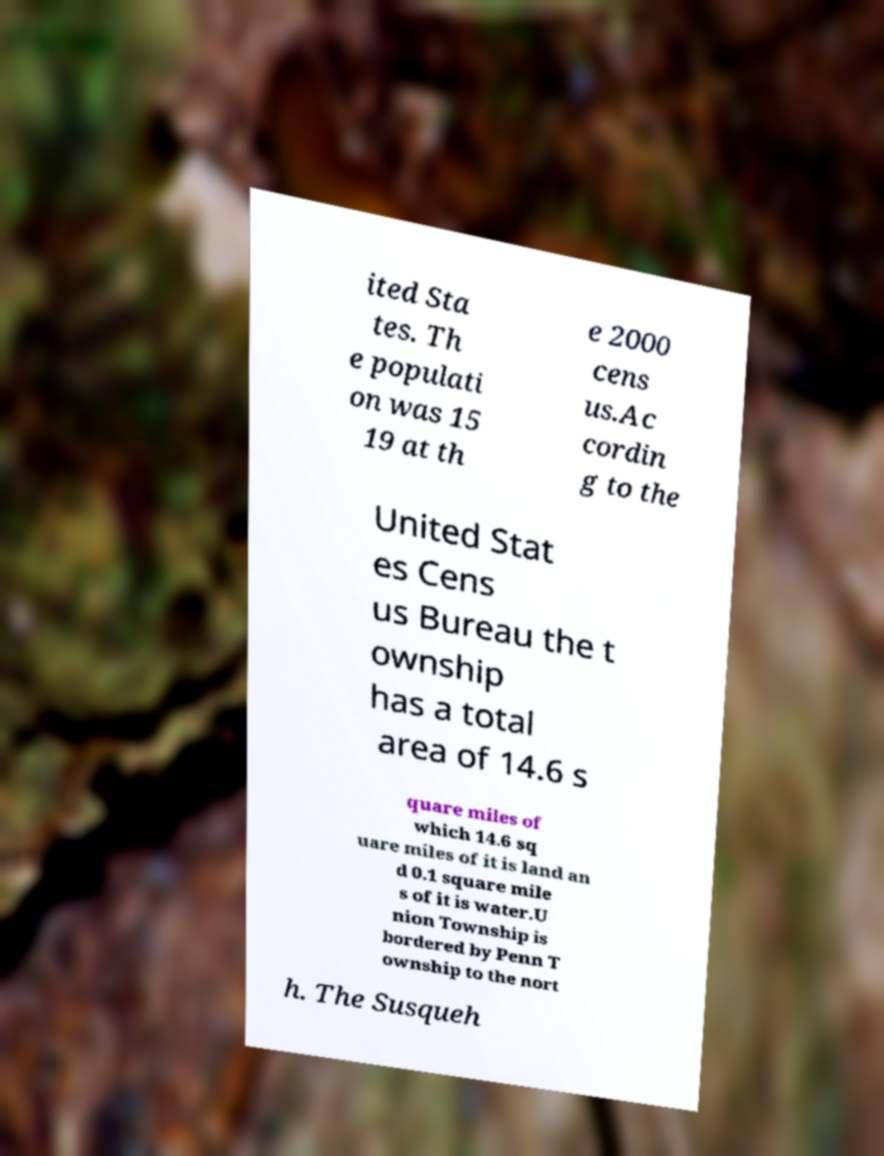What messages or text are displayed in this image? I need them in a readable, typed format. ited Sta tes. Th e populati on was 15 19 at th e 2000 cens us.Ac cordin g to the United Stat es Cens us Bureau the t ownship has a total area of 14.6 s quare miles of which 14.6 sq uare miles of it is land an d 0.1 square mile s of it is water.U nion Township is bordered by Penn T ownship to the nort h. The Susqueh 